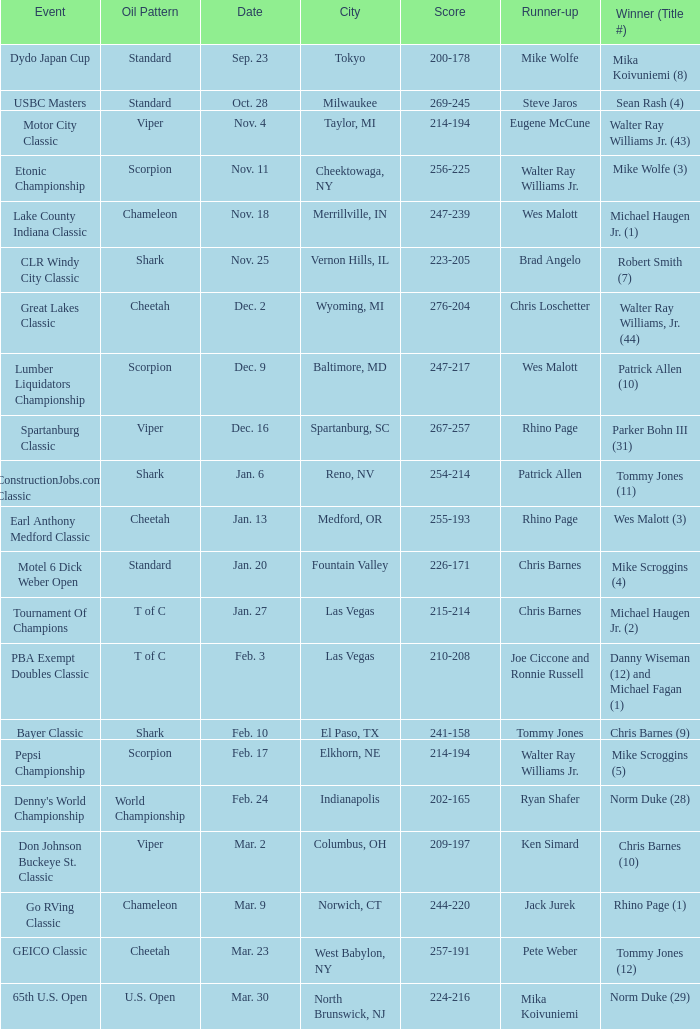Which Score has an Event of constructionjobs.com classic? 254-214. 